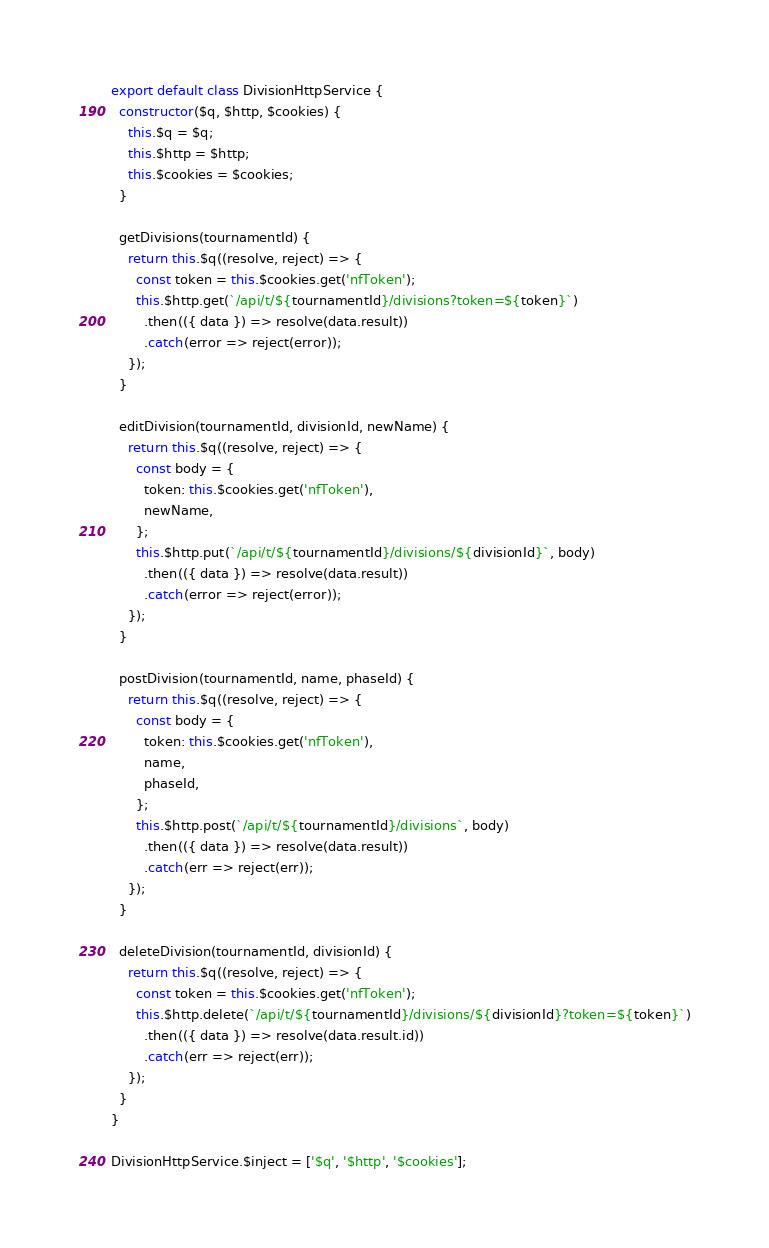<code> <loc_0><loc_0><loc_500><loc_500><_JavaScript_>export default class DivisionHttpService {
  constructor($q, $http, $cookies) {
    this.$q = $q;
    this.$http = $http;
    this.$cookies = $cookies;
  }

  getDivisions(tournamentId) {
    return this.$q((resolve, reject) => {
      const token = this.$cookies.get('nfToken');
      this.$http.get(`/api/t/${tournamentId}/divisions?token=${token}`)
        .then(({ data }) => resolve(data.result))
        .catch(error => reject(error));
    });
  }

  editDivision(tournamentId, divisionId, newName) {
    return this.$q((resolve, reject) => {
      const body = {
        token: this.$cookies.get('nfToken'),
        newName,
      };
      this.$http.put(`/api/t/${tournamentId}/divisions/${divisionId}`, body)
        .then(({ data }) => resolve(data.result))
        .catch(error => reject(error));
    });
  }

  postDivision(tournamentId, name, phaseId) {
    return this.$q((resolve, reject) => {
      const body = {
        token: this.$cookies.get('nfToken'),
        name,
        phaseId,
      };
      this.$http.post(`/api/t/${tournamentId}/divisions`, body)
        .then(({ data }) => resolve(data.result))
        .catch(err => reject(err));
    });
  }

  deleteDivision(tournamentId, divisionId) {
    return this.$q((resolve, reject) => {
      const token = this.$cookies.get('nfToken');
      this.$http.delete(`/api/t/${tournamentId}/divisions/${divisionId}?token=${token}`)
        .then(({ data }) => resolve(data.result.id))
        .catch(err => reject(err));
    });
  }
}

DivisionHttpService.$inject = ['$q', '$http', '$cookies'];
</code> 